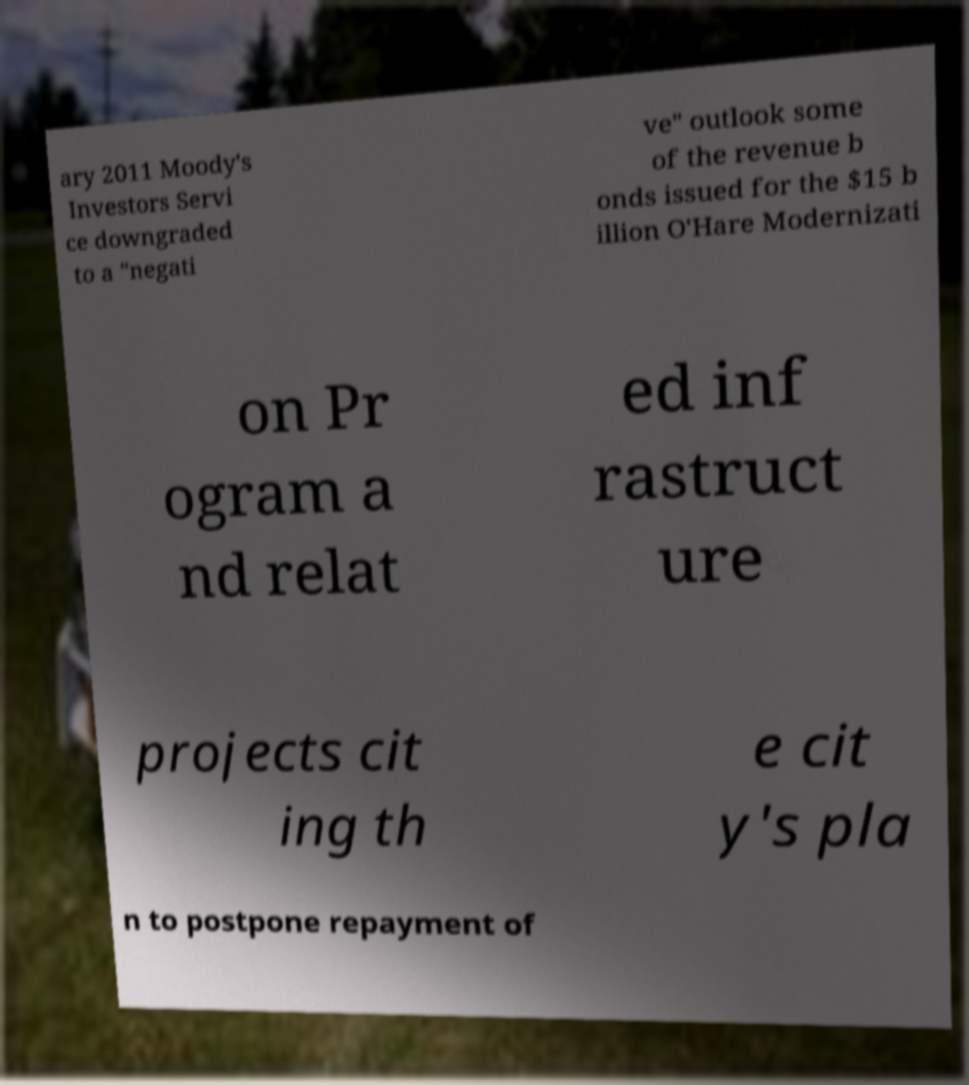Can you read and provide the text displayed in the image?This photo seems to have some interesting text. Can you extract and type it out for me? ary 2011 Moody's Investors Servi ce downgraded to a "negati ve" outlook some of the revenue b onds issued for the $15 b illion O'Hare Modernizati on Pr ogram a nd relat ed inf rastruct ure projects cit ing th e cit y's pla n to postpone repayment of 